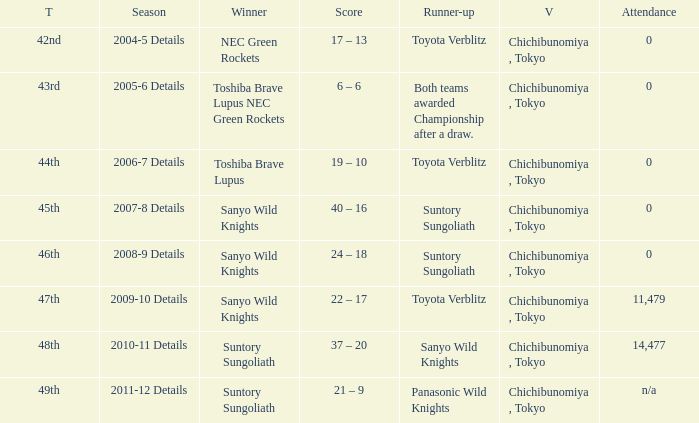What is the Attendance number when the runner-up was suntory sungoliath, and a Title of 46th? 0.0. 